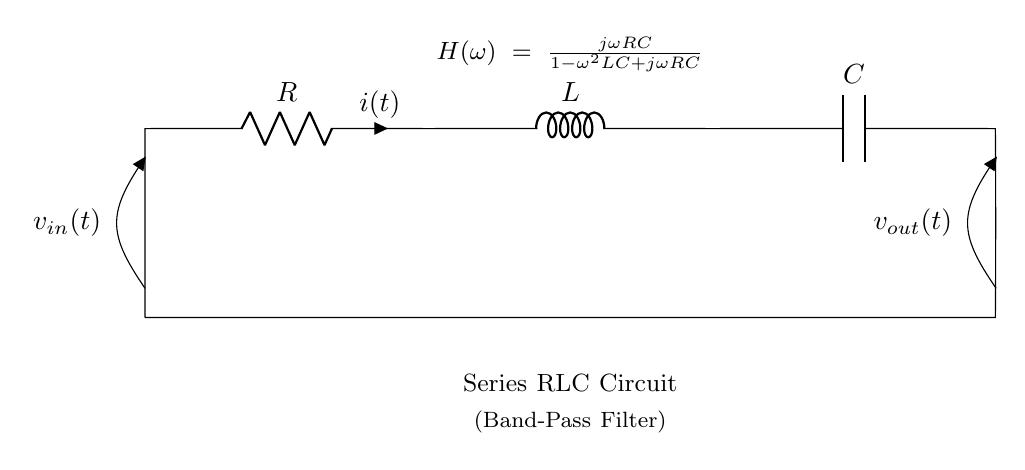What components are present in this circuit? The circuit includes a resistor, an inductor, and a capacitor, all connected in series.
Answer: Resistor, Inductor, Capacitor What is the input voltage labeled in the circuit? The input voltage is indicated on the left side of the circuit as v_in(t).
Answer: v_in(t) What type of filter does this circuit represent? The circuit is labeled as a band-pass filter, which indicates it allows a specific range of frequencies to pass through while attenuating others.
Answer: Band-pass filter What is the transfer function of this circuit? The transfer function is shown in the circuit diagram as H(ω) = jωRC/(1 - ω²LC + jωRC), detailing how the output relates to the input.
Answer: jωRC/(1 - ω²LC + jωRC) How many components are in the circuit? There are three main components: a resistor, an inductor, and a capacitor.
Answer: Three At what position is the output voltage measured? The output voltage is measured at the right side of the circuit, denoted as v_out(t).
Answer: v_out(t) Why is this circuit classified as a series configuration? The components are connected end-to-end, with the current flowing through each component in sequence, which defines a series configuration.
Answer: Series configuration 